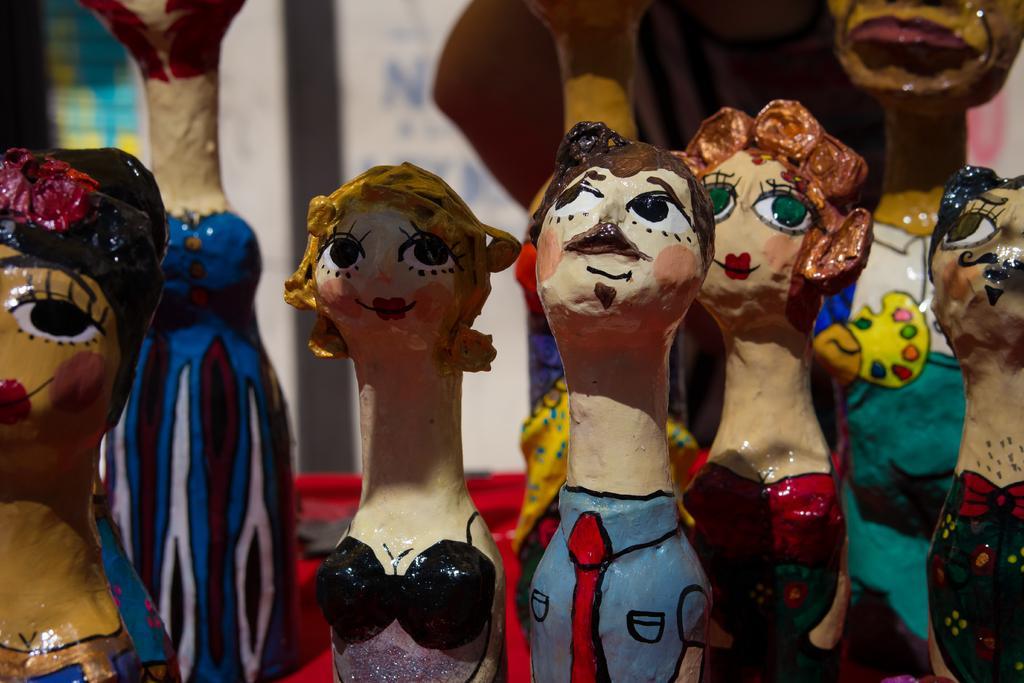Can you describe this image briefly? In this picture, we can see a few toys and the blurred background. 